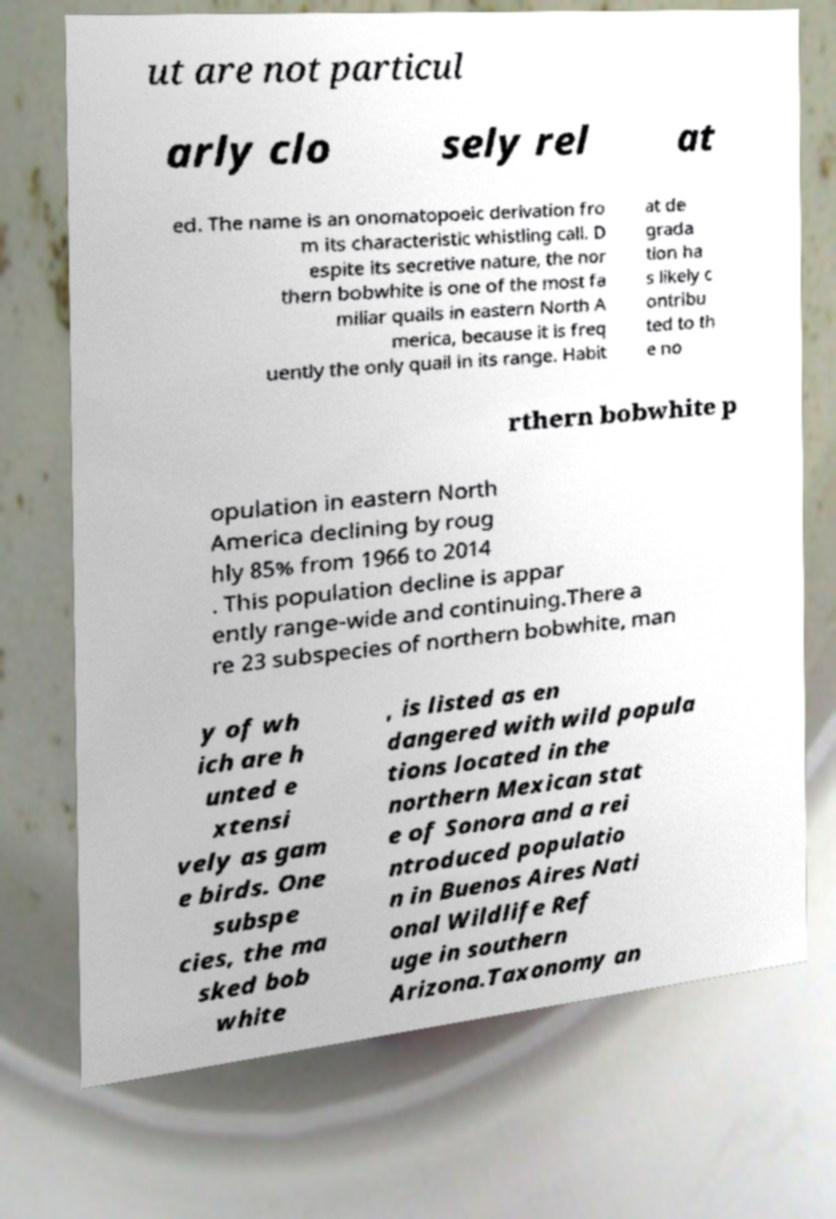Could you assist in decoding the text presented in this image and type it out clearly? ut are not particul arly clo sely rel at ed. The name is an onomatopoeic derivation fro m its characteristic whistling call. D espite its secretive nature, the nor thern bobwhite is one of the most fa miliar quails in eastern North A merica, because it is freq uently the only quail in its range. Habit at de grada tion ha s likely c ontribu ted to th e no rthern bobwhite p opulation in eastern North America declining by roug hly 85% from 1966 to 2014 . This population decline is appar ently range-wide and continuing.There a re 23 subspecies of northern bobwhite, man y of wh ich are h unted e xtensi vely as gam e birds. One subspe cies, the ma sked bob white , is listed as en dangered with wild popula tions located in the northern Mexican stat e of Sonora and a rei ntroduced populatio n in Buenos Aires Nati onal Wildlife Ref uge in southern Arizona.Taxonomy an 